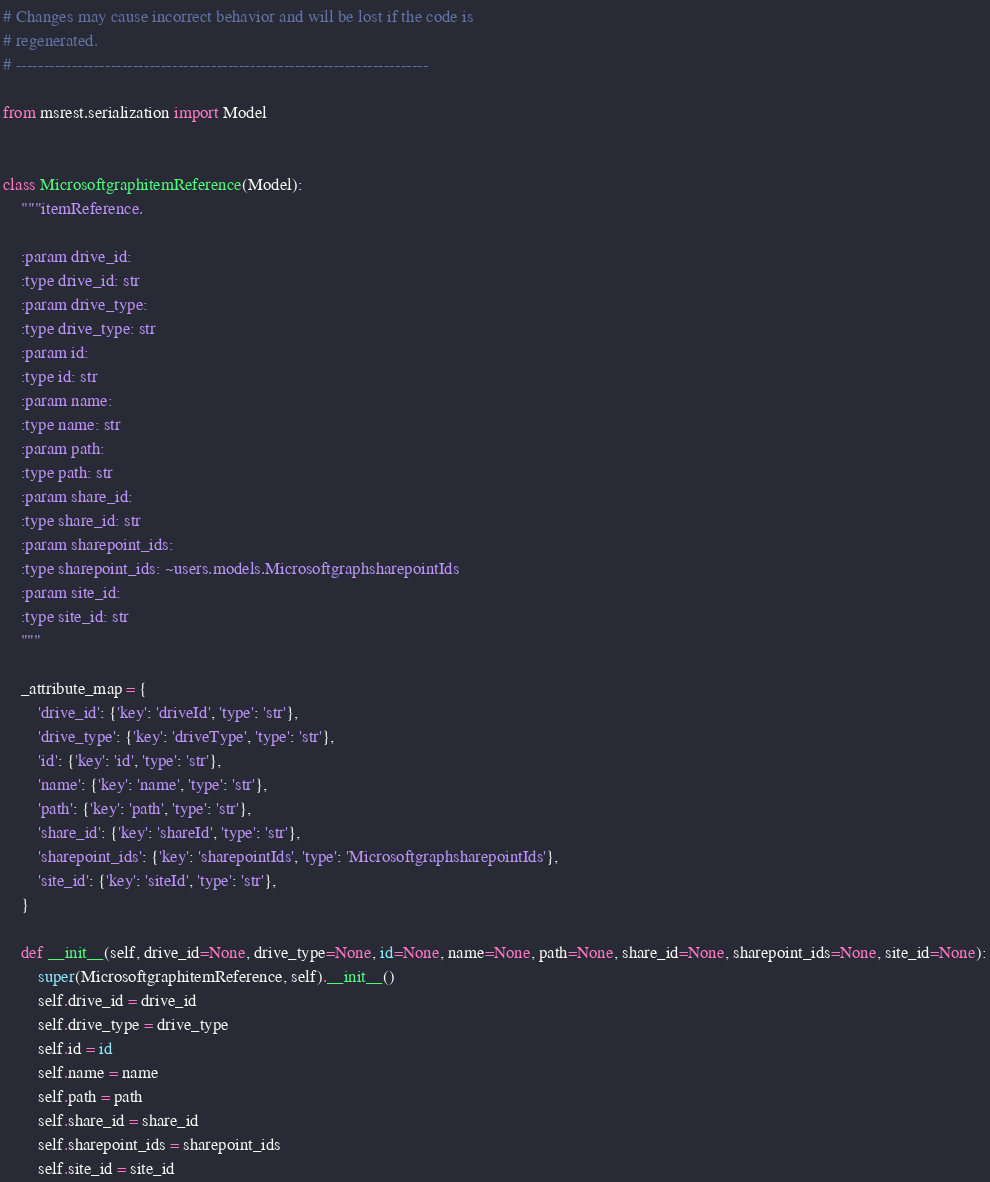Convert code to text. <code><loc_0><loc_0><loc_500><loc_500><_Python_># Changes may cause incorrect behavior and will be lost if the code is
# regenerated.
# --------------------------------------------------------------------------

from msrest.serialization import Model


class MicrosoftgraphitemReference(Model):
    """itemReference.

    :param drive_id:
    :type drive_id: str
    :param drive_type:
    :type drive_type: str
    :param id:
    :type id: str
    :param name:
    :type name: str
    :param path:
    :type path: str
    :param share_id:
    :type share_id: str
    :param sharepoint_ids:
    :type sharepoint_ids: ~users.models.MicrosoftgraphsharepointIds
    :param site_id:
    :type site_id: str
    """

    _attribute_map = {
        'drive_id': {'key': 'driveId', 'type': 'str'},
        'drive_type': {'key': 'driveType', 'type': 'str'},
        'id': {'key': 'id', 'type': 'str'},
        'name': {'key': 'name', 'type': 'str'},
        'path': {'key': 'path', 'type': 'str'},
        'share_id': {'key': 'shareId', 'type': 'str'},
        'sharepoint_ids': {'key': 'sharepointIds', 'type': 'MicrosoftgraphsharepointIds'},
        'site_id': {'key': 'siteId', 'type': 'str'},
    }

    def __init__(self, drive_id=None, drive_type=None, id=None, name=None, path=None, share_id=None, sharepoint_ids=None, site_id=None):
        super(MicrosoftgraphitemReference, self).__init__()
        self.drive_id = drive_id
        self.drive_type = drive_type
        self.id = id
        self.name = name
        self.path = path
        self.share_id = share_id
        self.sharepoint_ids = sharepoint_ids
        self.site_id = site_id
</code> 